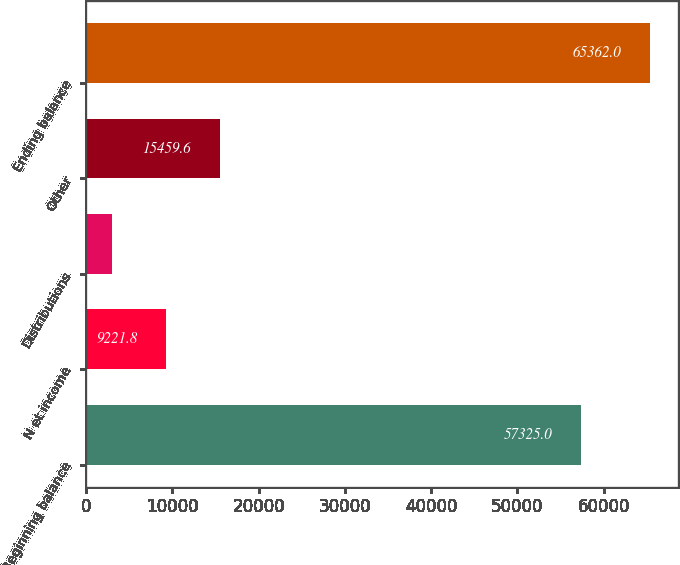Convert chart. <chart><loc_0><loc_0><loc_500><loc_500><bar_chart><fcel>Beginning balance<fcel>N et income<fcel>Distributions<fcel>Other<fcel>Ending balance<nl><fcel>57325<fcel>9221.8<fcel>2984<fcel>15459.6<fcel>65362<nl></chart> 